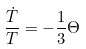Convert formula to latex. <formula><loc_0><loc_0><loc_500><loc_500>\frac { \dot { T } } { T } = - \frac { 1 } { 3 } \Theta</formula> 